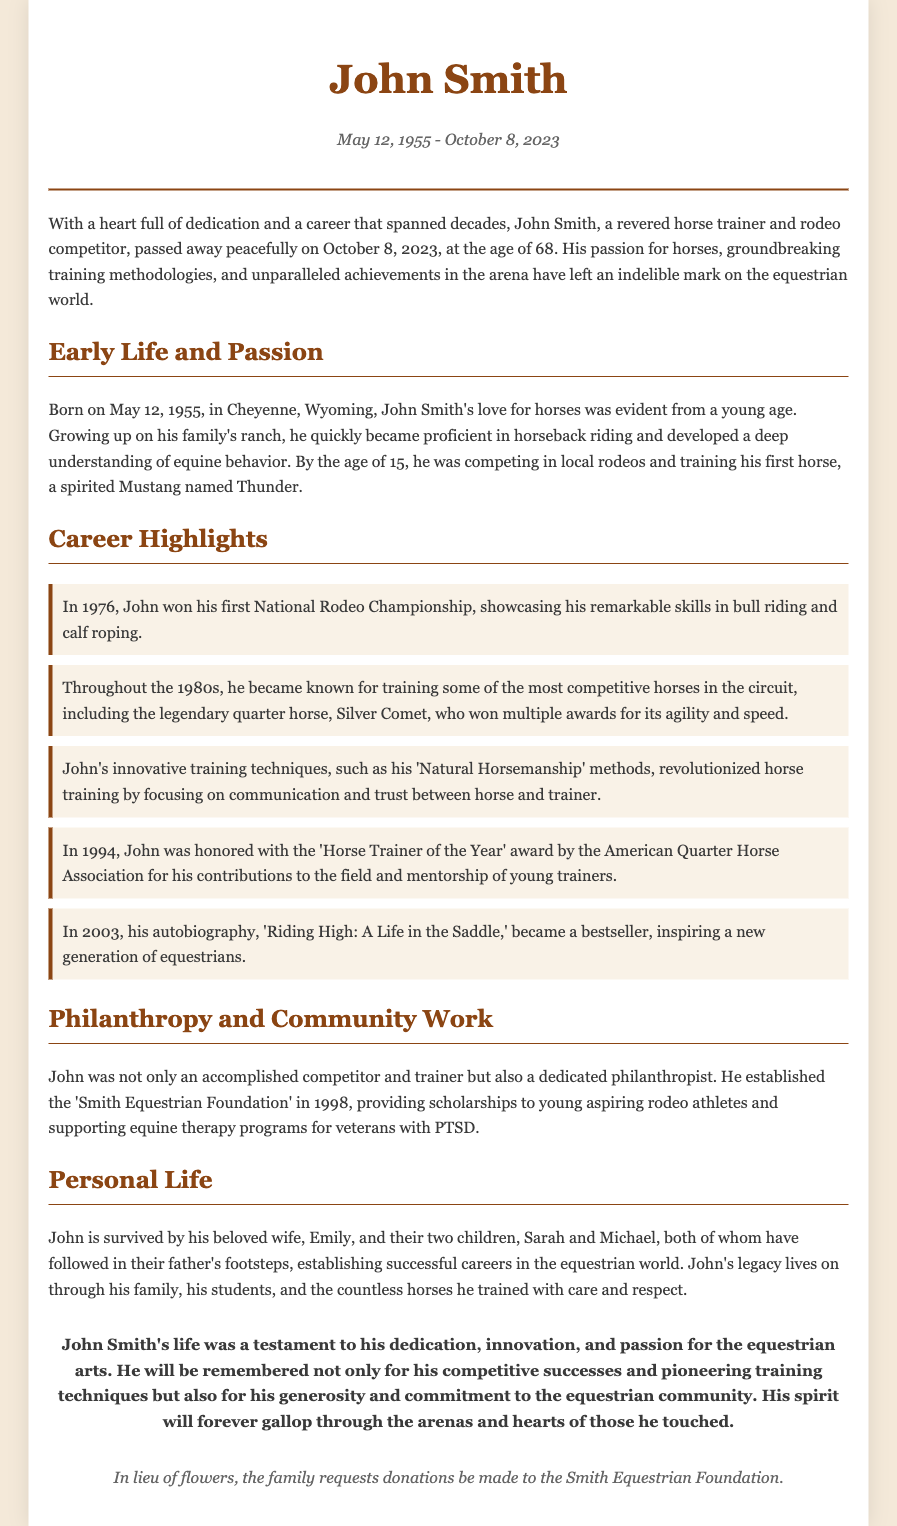What was John Smith's date of birth? The date of birth for John Smith is provided in the document, which states "Born on May 12, 1955."
Answer: May 12, 1955 What year did John Smith establish the 'Smith Equestrian Foundation'? The document specifies that the foundation was established in 1998.
Answer: 1998 Which horse did John Smith train that won multiple awards? The document mentions the legendary quarter horse named Silver Comet as the horse that won multiple awards.
Answer: Silver Comet What award did John Smith receive in 1994? According to the document, John was honored with the 'Horse Trainer of the Year' award.
Answer: Horse Trainer of the Year What did John Smith's autobiography title? The document states that John's autobiography is titled 'Riding High: A Life in the Saddle.'
Answer: Riding High: A Life in the Saddle How many children did John Smith have? The document states that John Smith is survived by two children.
Answer: Two What is a key focus of John Smith's training techniques? The document describes John’s innovative training techniques focusing on "communication and trust" between horse and trainer.
Answer: Communication and trust What age did John Smith pass away? The document states that John Smith passed away at the age of 68.
Answer: 68 What was John Smith's major competition achievement in 1976? The document indicates that John won his first National Rodeo Championship in 1976.
Answer: National Rodeo Championship 